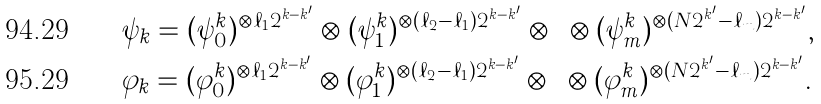Convert formula to latex. <formula><loc_0><loc_0><loc_500><loc_500>& \psi _ { k } = ( \psi ^ { k } _ { 0 } ) ^ { \otimes \ell _ { 1 } 2 ^ { k - k ^ { \prime } } } \otimes ( \psi ^ { k } _ { 1 } ) ^ { \otimes ( \ell _ { 2 } - \ell _ { 1 } ) 2 ^ { k - k ^ { \prime } } } \otimes \cdots \otimes ( \psi ^ { k } _ { m } ) ^ { \otimes ( N 2 ^ { k ^ { \prime } } - \ell _ { m } ) 2 ^ { k - k ^ { \prime } } } , \\ & \varphi _ { k } = ( \varphi ^ { k } _ { 0 } ) ^ { \otimes \ell _ { 1 } 2 ^ { k - k ^ { \prime } } } \otimes ( \varphi ^ { k } _ { 1 } ) ^ { \otimes ( \ell _ { 2 } - \ell _ { 1 } ) 2 ^ { k - k ^ { \prime } } } \otimes \cdots \otimes ( \varphi ^ { k } _ { m } ) ^ { \otimes ( N 2 ^ { k ^ { \prime } } - \ell _ { m } ) 2 ^ { k - k ^ { \prime } } } .</formula> 